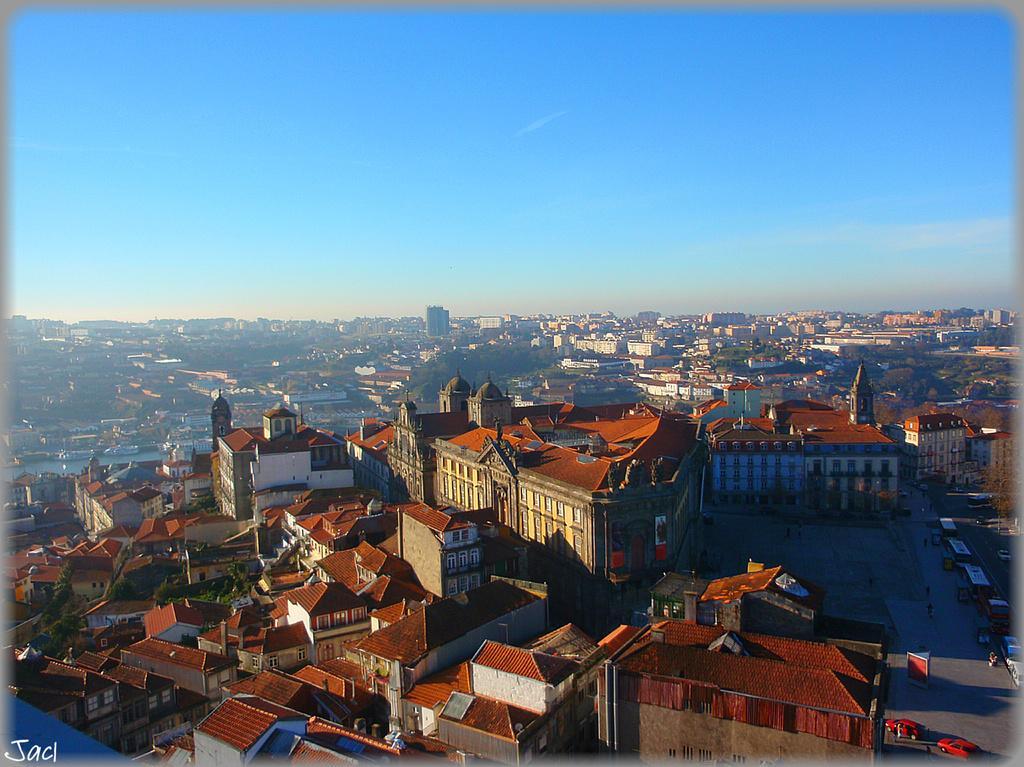Can you describe this image briefly? In this image we can see many buildings with windows. In the background there is sky. Also there are vehicles. In the left bottom corner something is written. 